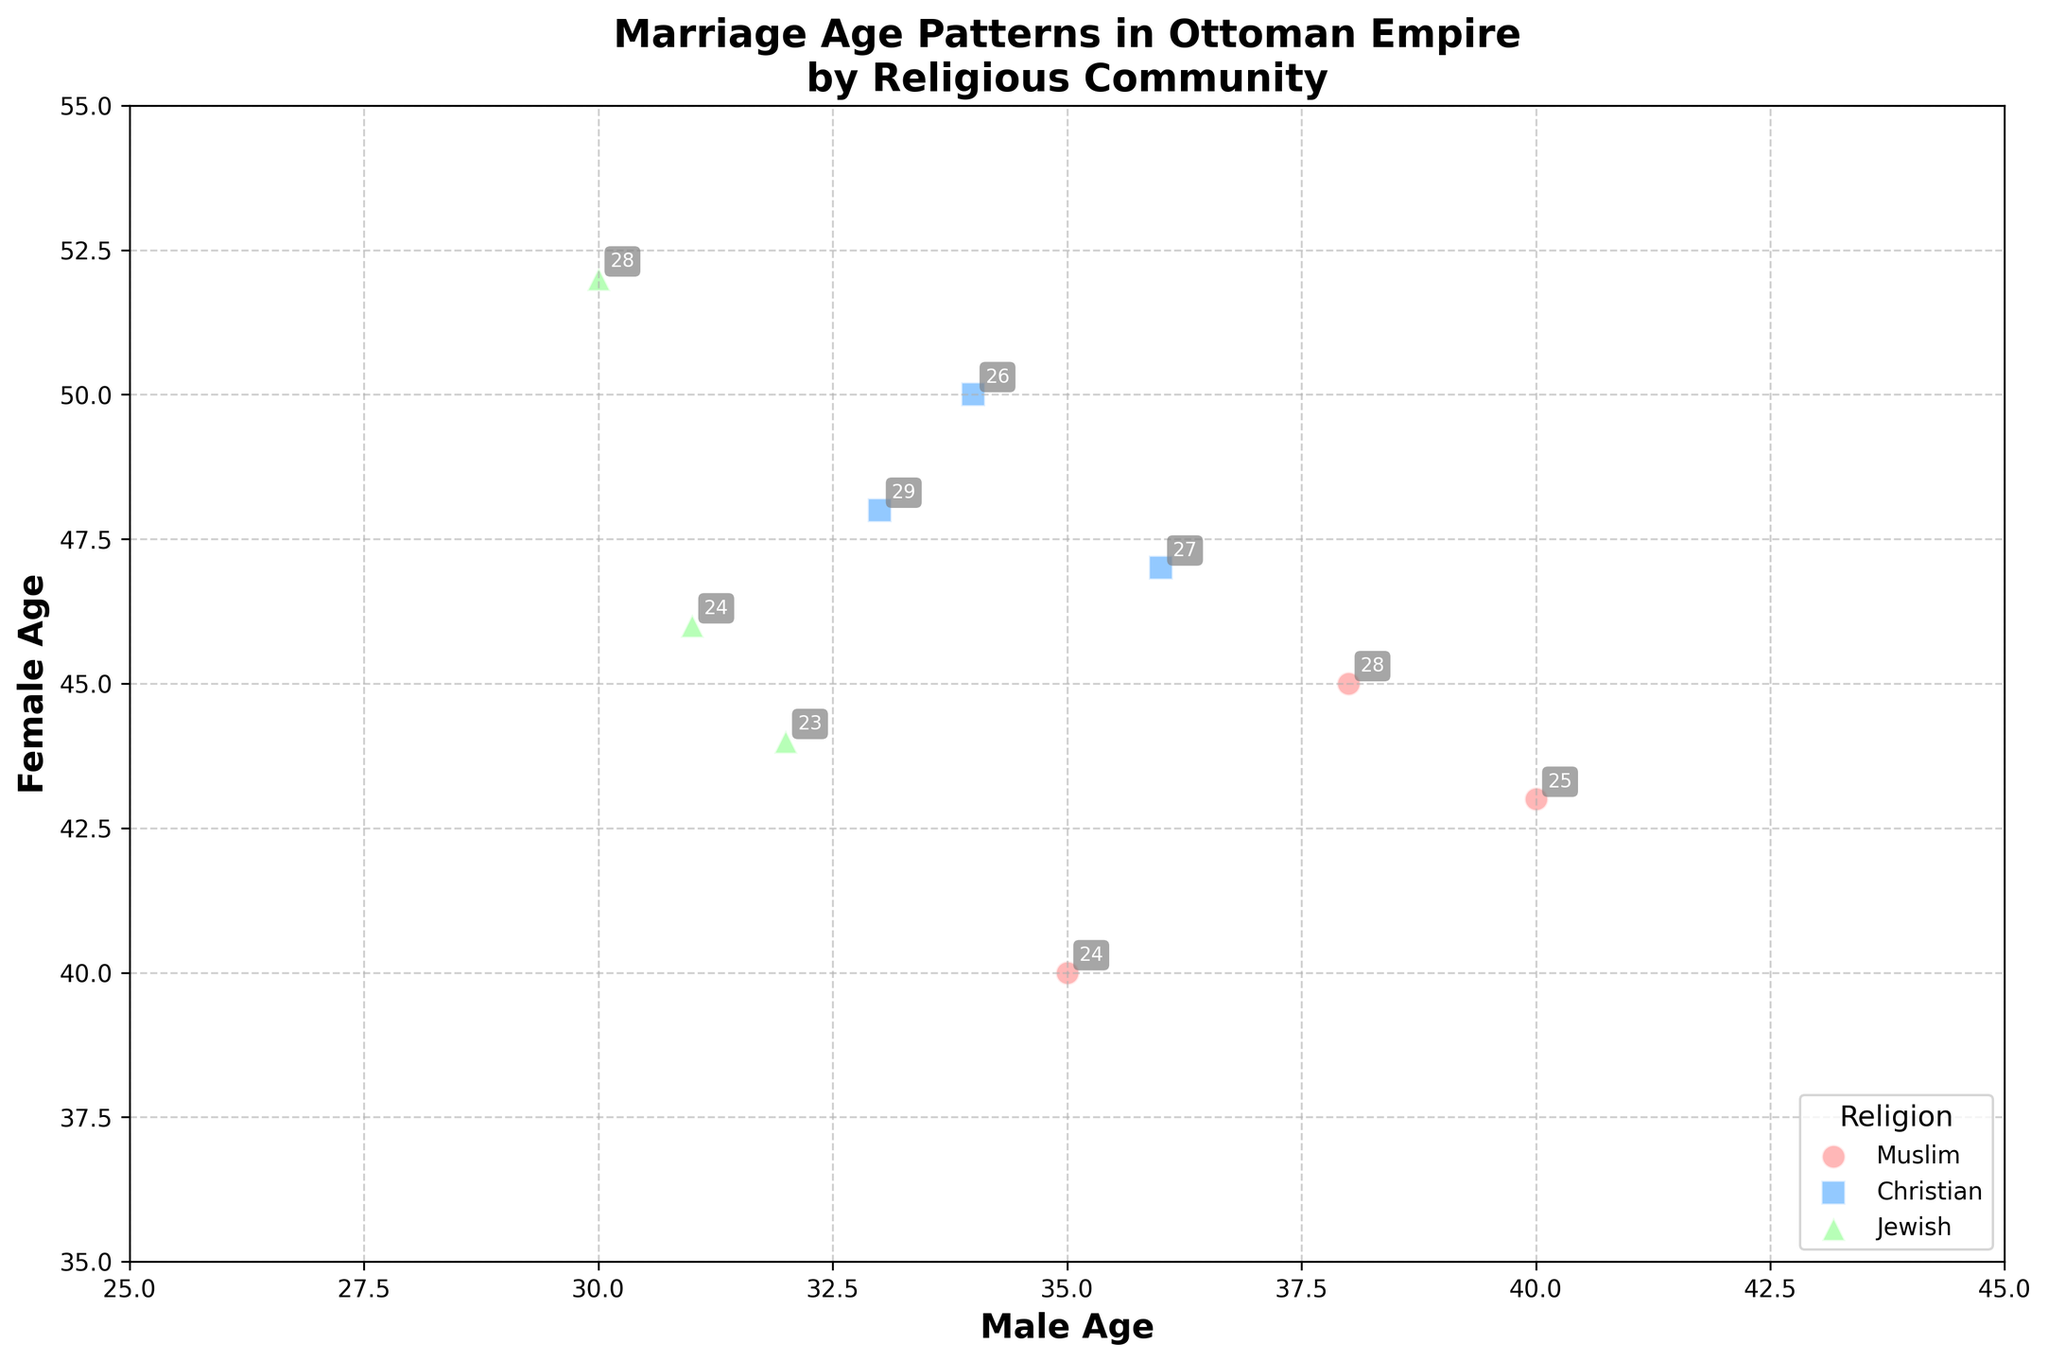How many religious communities are represented in the plot? There are three distinct colors and markers representing each religious community in the scatter plot. This corresponds to the three religious communities in the data.
Answer: 3 What is the maximum marriage age for females in the Jewish community? By looking at the points with the green markers (representing the Jewish community), the maximum female marriage age is noted next to the point with coordinates that include the highest value, which is 52.
Answer: 52 Which religious community has the youngest recorded male marriage age? Identify the scatter points with the lowest x-coordinate values for each color/marker. The Muslim community (red circles) has a point at x = 24.
Answer: Muslim What's the average recorded female marriage age for Muslims? The data for Muslims shows female ages of 40, 45, and 43. Summing these and then dividing by 3: (40 + 45 + 43)/3 = 128/3 ≈ 42.67.
Answer: ~42.67 Compare the average male marriage age between Christians and Jews. Christians have male ages 26, 27, and 29 (average = (26+27+29)/3 = 27.33). Jews have male ages 23, 24, and 28 (average = (23+24+28)/3 = 25). The Christian average is higher.
Answer: Christians ~27.33, Jews ~25 Which community shows the largest age difference between males and females at any data point? Check each point for each community and calculate the differences. The Jewish community has a point with male age 28 and female age 52, giving a difference of 24, which is the largest difference.
Answer: Jewish What does the number next to each scatter point represent? The numbers next to each scatter point represent the marriage age for that specific data point.
Answer: Marriage Age For which religious community does the data show the least variation in male marriage ages? Observe the spread of male ages for each community. The Jewish community shows male ages of 23, 24, and 28, which is the smallest range (5 years) compared to others.
Answer: Jewish Which community has the point with the closest male and female marriage ages? Check all points for each community where the difference between male and female ages are minimal. For Muslims, 25 (Male) and 43 (Female) differ by 2 years, which is the closest.
Answer: Muslim 